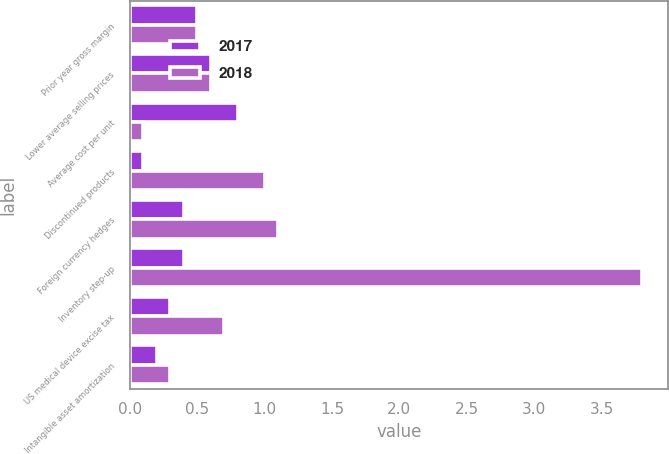<chart> <loc_0><loc_0><loc_500><loc_500><stacked_bar_chart><ecel><fcel>Prior year gross margin<fcel>Lower average selling prices<fcel>Average cost per unit<fcel>Discontinued products<fcel>Foreign currency hedges<fcel>Inventory step-up<fcel>US medical device excise tax<fcel>Intangible asset amortization<nl><fcel>2017<fcel>0.5<fcel>0.6<fcel>0.8<fcel>0.1<fcel>0.4<fcel>0.4<fcel>0.3<fcel>0.2<nl><fcel>2018<fcel>0.5<fcel>0.6<fcel>0.1<fcel>1<fcel>1.1<fcel>3.8<fcel>0.7<fcel>0.3<nl></chart> 